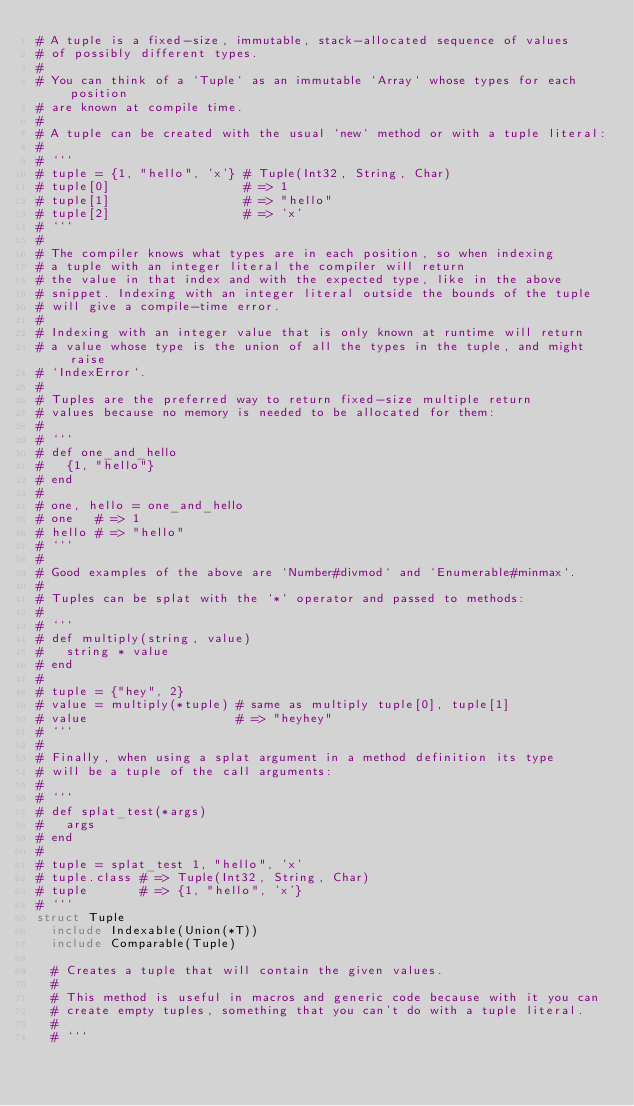Convert code to text. <code><loc_0><loc_0><loc_500><loc_500><_Crystal_># A tuple is a fixed-size, immutable, stack-allocated sequence of values
# of possibly different types.
#
# You can think of a `Tuple` as an immutable `Array` whose types for each position
# are known at compile time.
#
# A tuple can be created with the usual `new` method or with a tuple literal:
#
# ```
# tuple = {1, "hello", 'x'} # Tuple(Int32, String, Char)
# tuple[0]                  # => 1
# tuple[1]                  # => "hello"
# tuple[2]                  # => 'x'
# ```
#
# The compiler knows what types are in each position, so when indexing
# a tuple with an integer literal the compiler will return
# the value in that index and with the expected type, like in the above
# snippet. Indexing with an integer literal outside the bounds of the tuple
# will give a compile-time error.
#
# Indexing with an integer value that is only known at runtime will return
# a value whose type is the union of all the types in the tuple, and might raise
# `IndexError`.
#
# Tuples are the preferred way to return fixed-size multiple return
# values because no memory is needed to be allocated for them:
#
# ```
# def one_and_hello
#   {1, "hello"}
# end
#
# one, hello = one_and_hello
# one   # => 1
# hello # => "hello"
# ```
#
# Good examples of the above are `Number#divmod` and `Enumerable#minmax`.
#
# Tuples can be splat with the `*` operator and passed to methods:
#
# ```
# def multiply(string, value)
#   string * value
# end
#
# tuple = {"hey", 2}
# value = multiply(*tuple) # same as multiply tuple[0], tuple[1]
# value                    # => "heyhey"
# ```
#
# Finally, when using a splat argument in a method definition its type
# will be a tuple of the call arguments:
#
# ```
# def splat_test(*args)
#   args
# end
#
# tuple = splat_test 1, "hello", 'x'
# tuple.class # => Tuple(Int32, String, Char)
# tuple       # => {1, "hello", 'x'}
# ```
struct Tuple
  include Indexable(Union(*T))
  include Comparable(Tuple)

  # Creates a tuple that will contain the given values.
  #
  # This method is useful in macros and generic code because with it you can
  # create empty tuples, something that you can't do with a tuple literal.
  #
  # ```</code> 